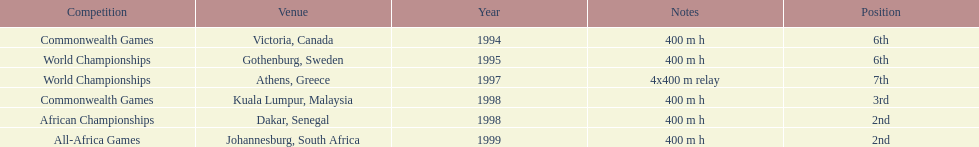Which year witnessed the highest number of competitions? 1998. 